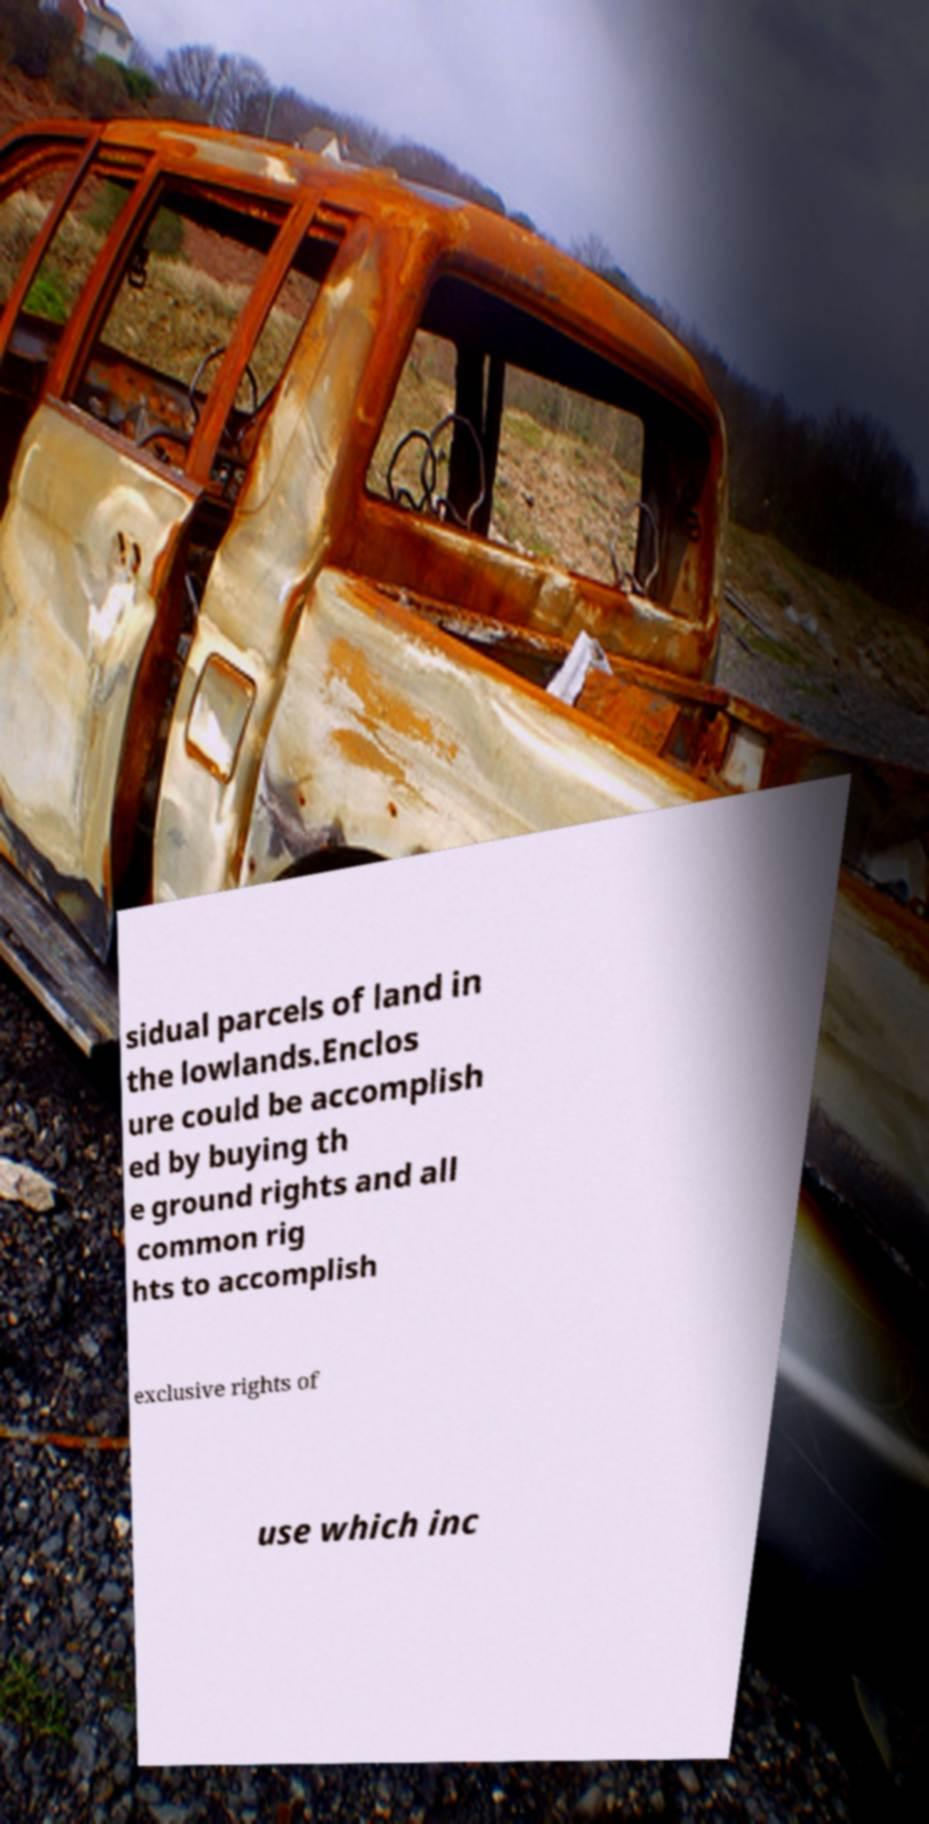Can you read and provide the text displayed in the image?This photo seems to have some interesting text. Can you extract and type it out for me? sidual parcels of land in the lowlands.Enclos ure could be accomplish ed by buying th e ground rights and all common rig hts to accomplish exclusive rights of use which inc 